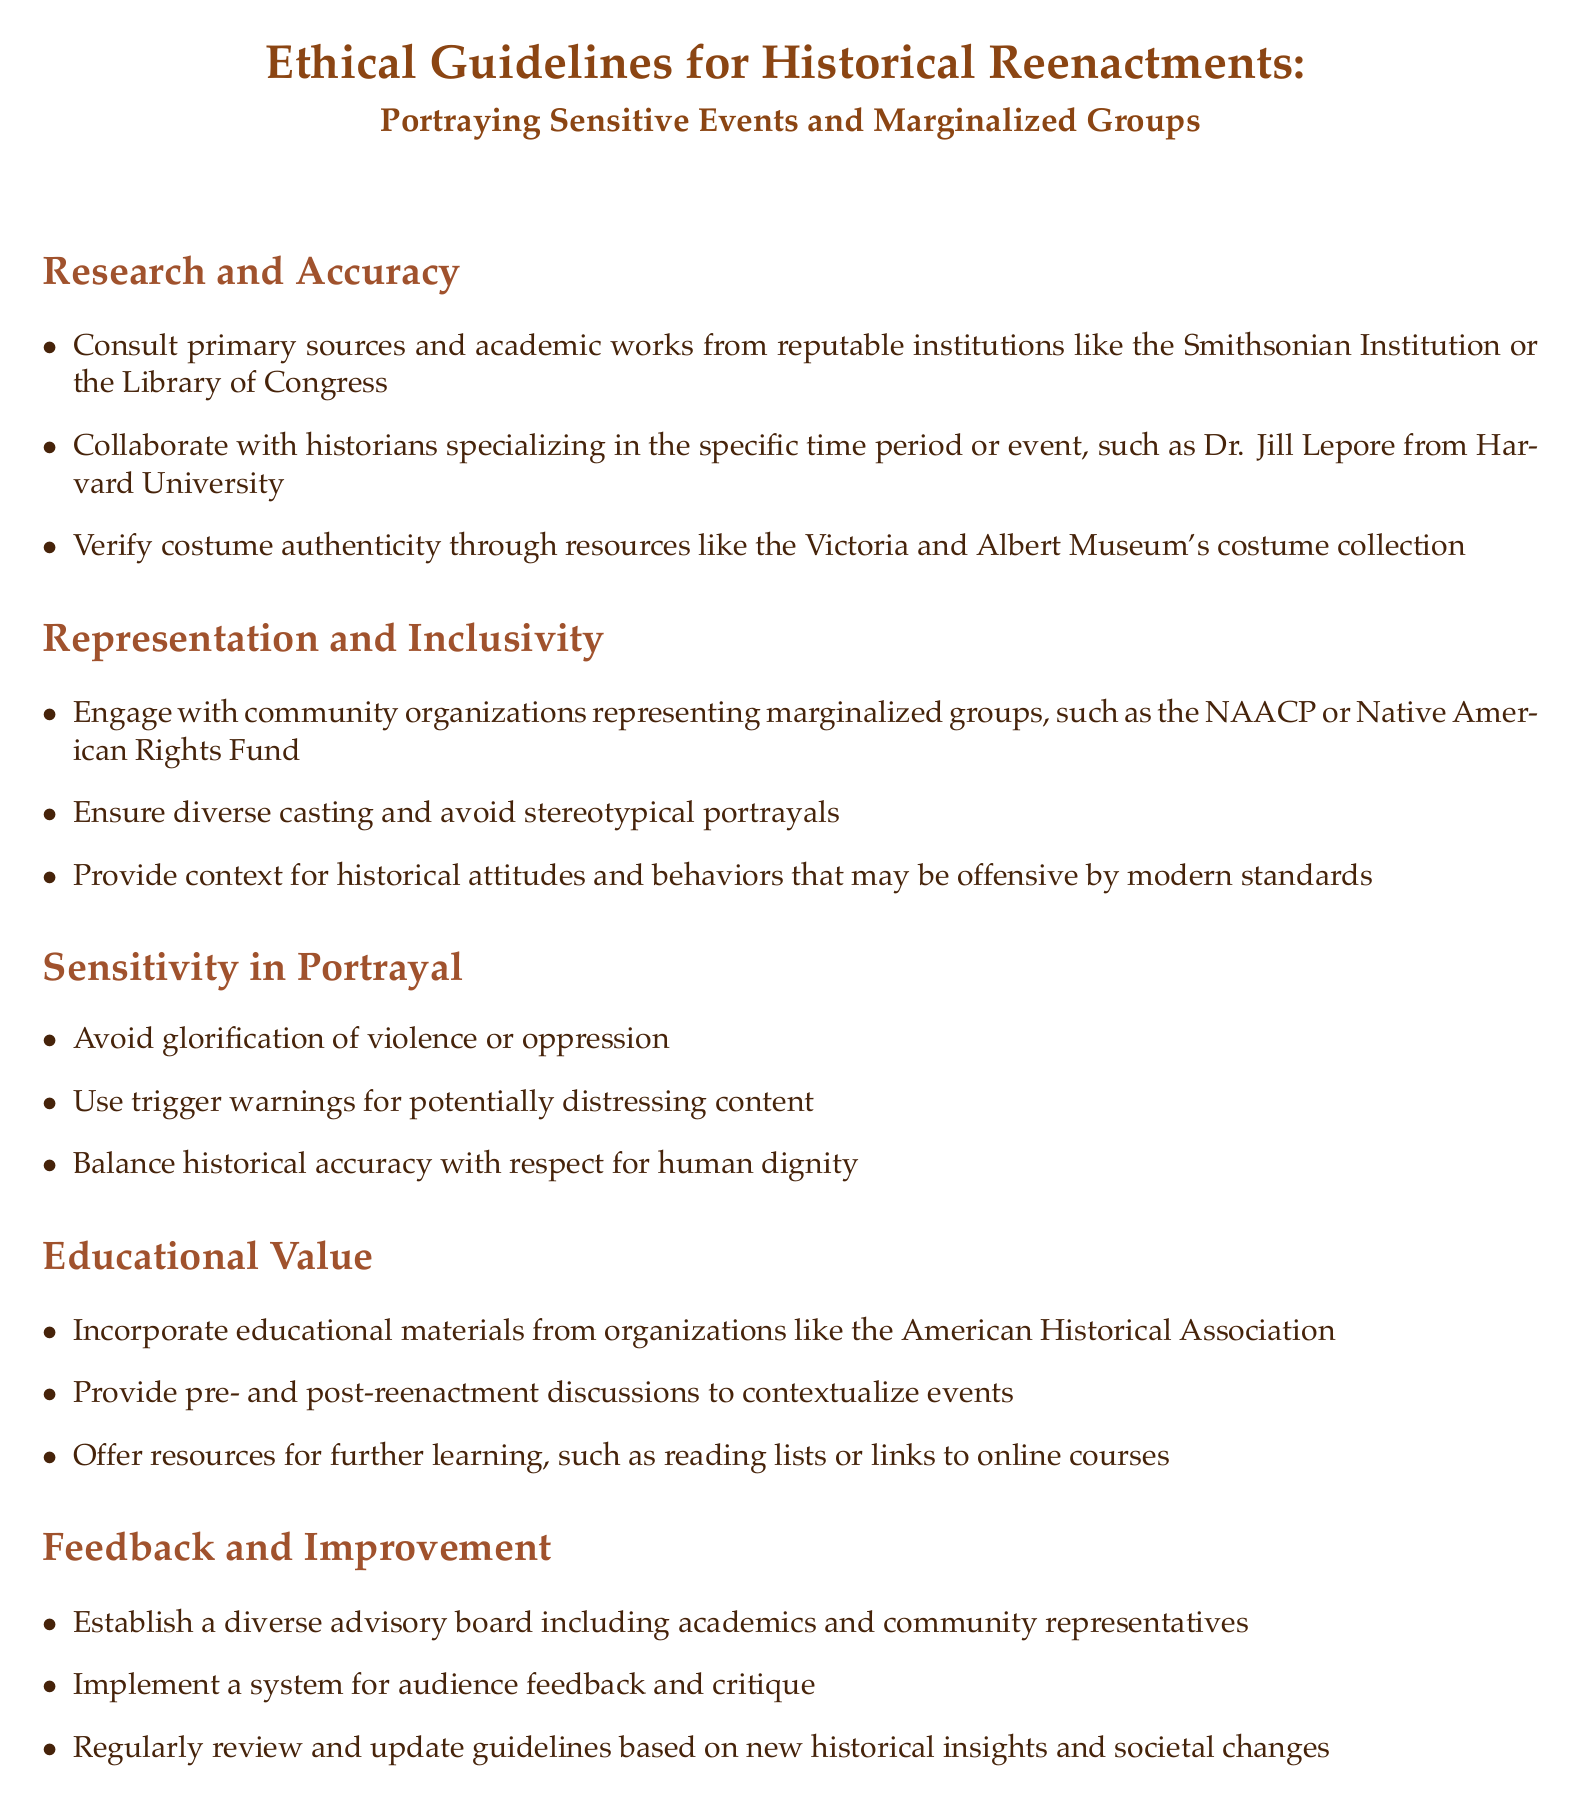What is the title of the document? The title of the document is found at the center of the first page and indicates the main subject it covers.
Answer: Ethical Guidelines for Historical Reenactments: Portraying Sensitive Events and Marginalized Groups Who should you collaborate with for historical accuracy? The document suggests collaboration with specialists in the specific time period or event for ensuring authenticity.
Answer: Historians Name a community organization mentioned for representation. The document lists organizations that can be engaged for representing marginalized groups.
Answer: NAACP What type of content should be accompanied by trigger warnings? The document addresses concerns regarding sensitive material that may affect participants or audiences, indicating the need for precautions.
Answer: Potentially distressing content What educational organization is referenced for materials? The document highlights the importance of providing educational resources from established organizations to enhance understanding.
Answer: American Historical Association What should be avoided in portrayals according to the guidelines? The guidelines emphasize the need to approach sensitive topics with respect and care, aiming to avoid harmful representations.
Answer: Glorification of violence or oppression How often should guidelines be reviewed? The document states a commitment to regularly update the guidelines in response to evolving historical knowledge and societal views.
Answer: Regularly What feature enhances the educational value of reenactments? The document indicates a method to deepen audience understanding by incorporating discussions around the reenactments.
Answer: Pre- and post-reenactment discussions What is the purpose of establishing a diverse advisory board? The document emphasizes the role of the advisory board in providing a range of perspectives to improve oversight and inclusivity in reenactments.
Answer: Feedback and improvement 